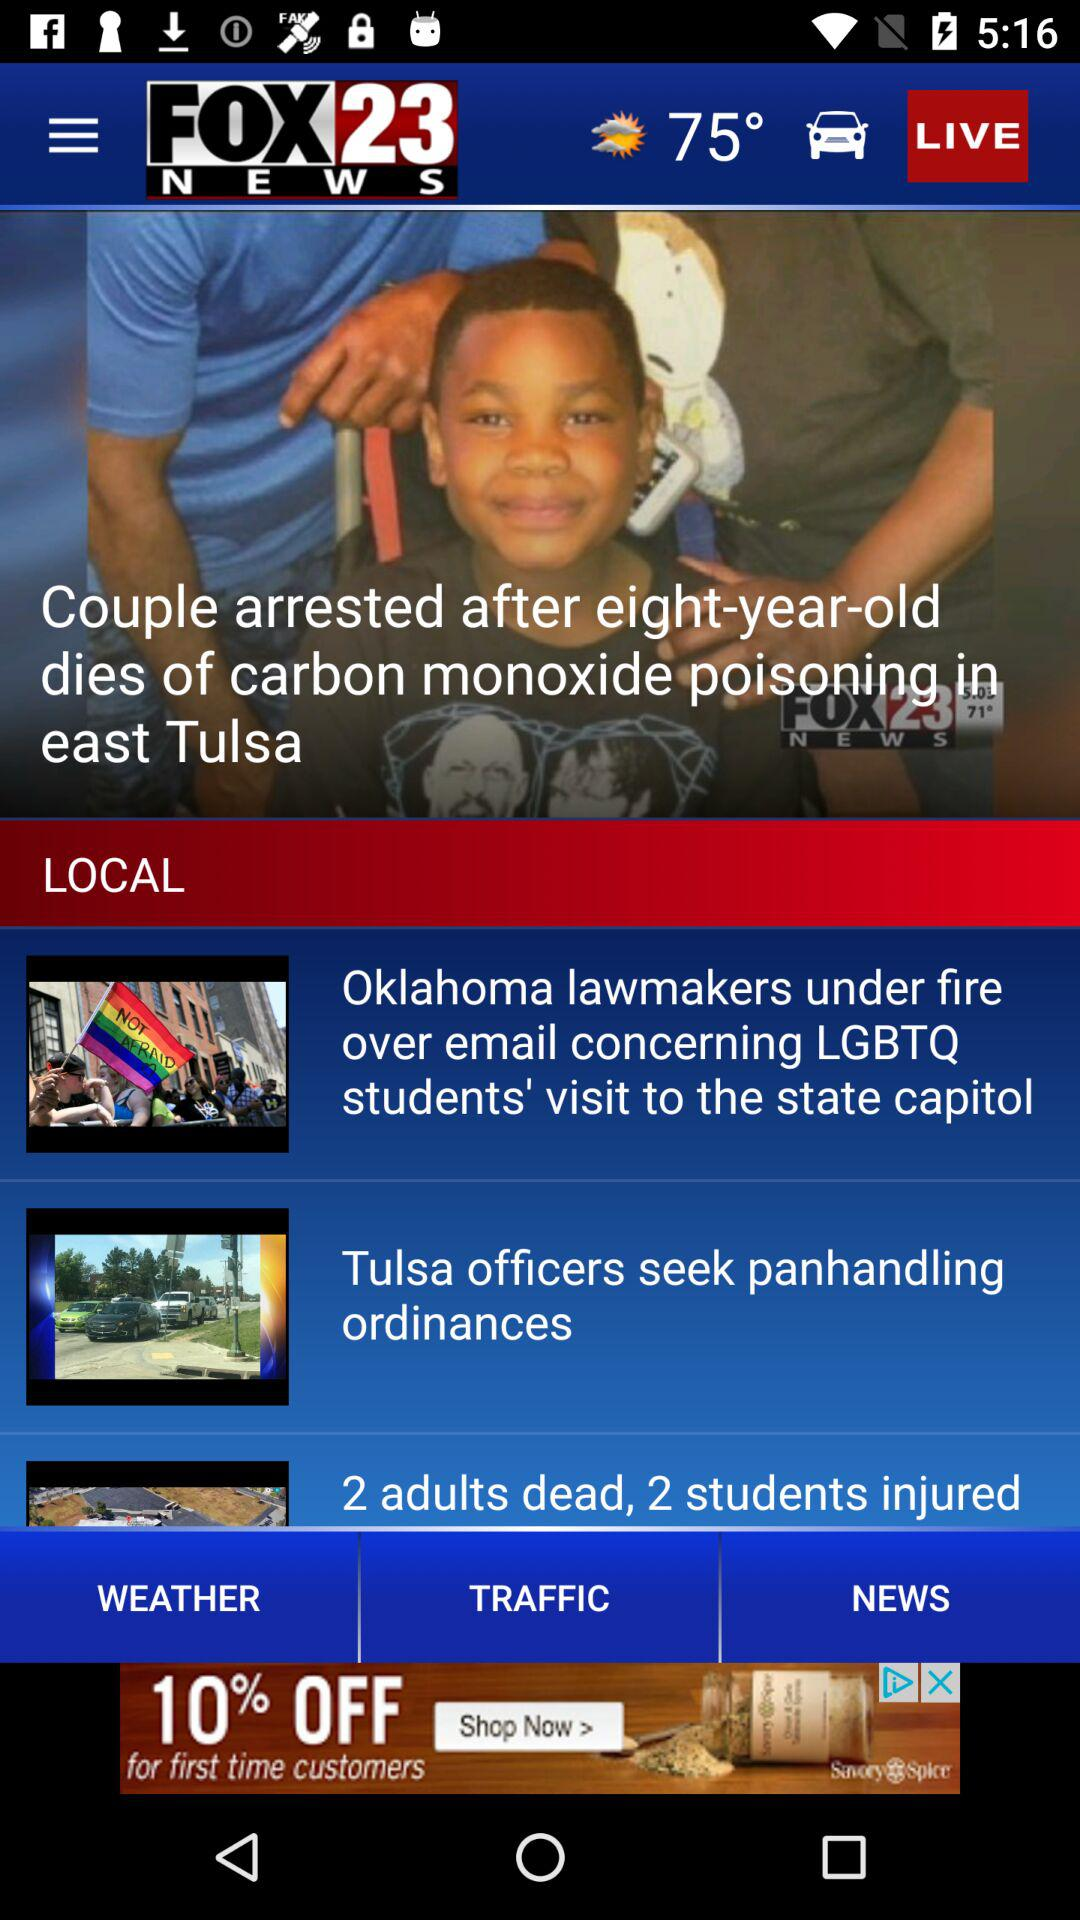What is the channel name? The channel name is "FOX23 NEWS". 